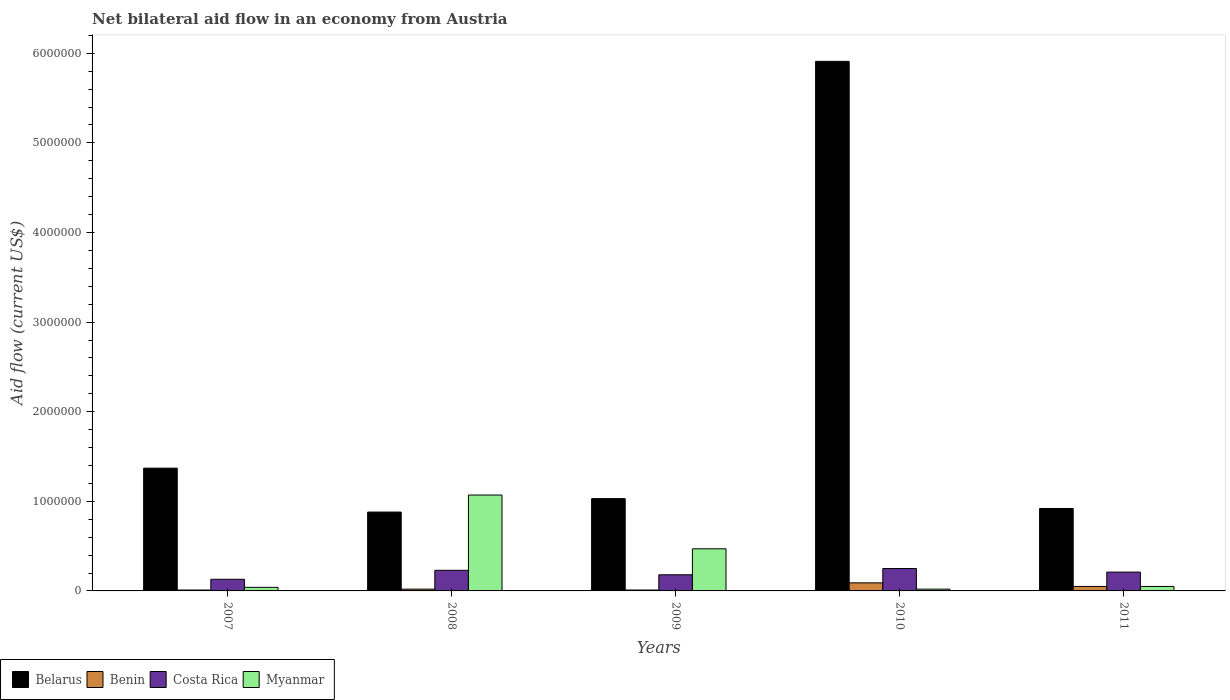How many groups of bars are there?
Make the answer very short. 5. Are the number of bars on each tick of the X-axis equal?
Ensure brevity in your answer.  Yes. How many bars are there on the 3rd tick from the left?
Give a very brief answer. 4. How many bars are there on the 5th tick from the right?
Keep it short and to the point. 4. In how many cases, is the number of bars for a given year not equal to the number of legend labels?
Your answer should be compact. 0. What is the net bilateral aid flow in Costa Rica in 2011?
Keep it short and to the point. 2.10e+05. Across all years, what is the maximum net bilateral aid flow in Belarus?
Offer a very short reply. 5.91e+06. What is the total net bilateral aid flow in Myanmar in the graph?
Provide a succinct answer. 1.65e+06. What is the difference between the net bilateral aid flow in Belarus in 2008 and the net bilateral aid flow in Costa Rica in 2011?
Provide a succinct answer. 6.70e+05. What is the average net bilateral aid flow in Belarus per year?
Your answer should be compact. 2.02e+06. In the year 2010, what is the difference between the net bilateral aid flow in Belarus and net bilateral aid flow in Costa Rica?
Your answer should be very brief. 5.66e+06. In how many years, is the net bilateral aid flow in Costa Rica greater than 2000000 US$?
Keep it short and to the point. 0. Is the difference between the net bilateral aid flow in Belarus in 2010 and 2011 greater than the difference between the net bilateral aid flow in Costa Rica in 2010 and 2011?
Keep it short and to the point. Yes. What is the difference between the highest and the second highest net bilateral aid flow in Benin?
Your answer should be compact. 4.00e+04. What is the difference between the highest and the lowest net bilateral aid flow in Costa Rica?
Make the answer very short. 1.20e+05. Is the sum of the net bilateral aid flow in Myanmar in 2008 and 2010 greater than the maximum net bilateral aid flow in Belarus across all years?
Your answer should be very brief. No. What does the 2nd bar from the left in 2007 represents?
Your answer should be very brief. Benin. What does the 4th bar from the right in 2008 represents?
Offer a very short reply. Belarus. Is it the case that in every year, the sum of the net bilateral aid flow in Belarus and net bilateral aid flow in Benin is greater than the net bilateral aid flow in Myanmar?
Provide a succinct answer. No. Are all the bars in the graph horizontal?
Offer a very short reply. No. How many years are there in the graph?
Offer a terse response. 5. Does the graph contain grids?
Your response must be concise. No. Where does the legend appear in the graph?
Provide a succinct answer. Bottom left. What is the title of the graph?
Give a very brief answer. Net bilateral aid flow in an economy from Austria. Does "Honduras" appear as one of the legend labels in the graph?
Ensure brevity in your answer.  No. What is the Aid flow (current US$) in Belarus in 2007?
Provide a succinct answer. 1.37e+06. What is the Aid flow (current US$) in Costa Rica in 2007?
Keep it short and to the point. 1.30e+05. What is the Aid flow (current US$) of Belarus in 2008?
Your response must be concise. 8.80e+05. What is the Aid flow (current US$) in Myanmar in 2008?
Provide a short and direct response. 1.07e+06. What is the Aid flow (current US$) in Belarus in 2009?
Provide a short and direct response. 1.03e+06. What is the Aid flow (current US$) of Benin in 2009?
Your response must be concise. 10000. What is the Aid flow (current US$) in Costa Rica in 2009?
Your answer should be compact. 1.80e+05. What is the Aid flow (current US$) in Belarus in 2010?
Your answer should be very brief. 5.91e+06. What is the Aid flow (current US$) in Benin in 2010?
Give a very brief answer. 9.00e+04. What is the Aid flow (current US$) of Costa Rica in 2010?
Your answer should be very brief. 2.50e+05. What is the Aid flow (current US$) in Myanmar in 2010?
Offer a terse response. 2.00e+04. What is the Aid flow (current US$) of Belarus in 2011?
Your answer should be very brief. 9.20e+05. What is the Aid flow (current US$) in Benin in 2011?
Your response must be concise. 5.00e+04. What is the Aid flow (current US$) of Costa Rica in 2011?
Provide a succinct answer. 2.10e+05. Across all years, what is the maximum Aid flow (current US$) in Belarus?
Keep it short and to the point. 5.91e+06. Across all years, what is the maximum Aid flow (current US$) of Benin?
Your answer should be compact. 9.00e+04. Across all years, what is the maximum Aid flow (current US$) in Myanmar?
Give a very brief answer. 1.07e+06. Across all years, what is the minimum Aid flow (current US$) in Belarus?
Your response must be concise. 8.80e+05. Across all years, what is the minimum Aid flow (current US$) of Costa Rica?
Provide a short and direct response. 1.30e+05. What is the total Aid flow (current US$) of Belarus in the graph?
Provide a short and direct response. 1.01e+07. What is the total Aid flow (current US$) in Benin in the graph?
Offer a very short reply. 1.80e+05. What is the total Aid flow (current US$) of Myanmar in the graph?
Provide a short and direct response. 1.65e+06. What is the difference between the Aid flow (current US$) in Benin in 2007 and that in 2008?
Offer a terse response. -10000. What is the difference between the Aid flow (current US$) in Costa Rica in 2007 and that in 2008?
Offer a terse response. -1.00e+05. What is the difference between the Aid flow (current US$) of Myanmar in 2007 and that in 2008?
Make the answer very short. -1.03e+06. What is the difference between the Aid flow (current US$) in Benin in 2007 and that in 2009?
Give a very brief answer. 0. What is the difference between the Aid flow (current US$) of Myanmar in 2007 and that in 2009?
Give a very brief answer. -4.30e+05. What is the difference between the Aid flow (current US$) of Belarus in 2007 and that in 2010?
Provide a succinct answer. -4.54e+06. What is the difference between the Aid flow (current US$) of Costa Rica in 2007 and that in 2010?
Keep it short and to the point. -1.20e+05. What is the difference between the Aid flow (current US$) in Belarus in 2007 and that in 2011?
Offer a very short reply. 4.50e+05. What is the difference between the Aid flow (current US$) of Benin in 2007 and that in 2011?
Provide a succinct answer. -4.00e+04. What is the difference between the Aid flow (current US$) in Belarus in 2008 and that in 2009?
Give a very brief answer. -1.50e+05. What is the difference between the Aid flow (current US$) in Benin in 2008 and that in 2009?
Offer a terse response. 10000. What is the difference between the Aid flow (current US$) in Costa Rica in 2008 and that in 2009?
Give a very brief answer. 5.00e+04. What is the difference between the Aid flow (current US$) in Myanmar in 2008 and that in 2009?
Offer a very short reply. 6.00e+05. What is the difference between the Aid flow (current US$) of Belarus in 2008 and that in 2010?
Ensure brevity in your answer.  -5.03e+06. What is the difference between the Aid flow (current US$) in Benin in 2008 and that in 2010?
Keep it short and to the point. -7.00e+04. What is the difference between the Aid flow (current US$) of Myanmar in 2008 and that in 2010?
Ensure brevity in your answer.  1.05e+06. What is the difference between the Aid flow (current US$) in Myanmar in 2008 and that in 2011?
Your answer should be very brief. 1.02e+06. What is the difference between the Aid flow (current US$) in Belarus in 2009 and that in 2010?
Provide a succinct answer. -4.88e+06. What is the difference between the Aid flow (current US$) of Costa Rica in 2009 and that in 2011?
Your answer should be very brief. -3.00e+04. What is the difference between the Aid flow (current US$) in Belarus in 2010 and that in 2011?
Your answer should be compact. 4.99e+06. What is the difference between the Aid flow (current US$) in Benin in 2010 and that in 2011?
Ensure brevity in your answer.  4.00e+04. What is the difference between the Aid flow (current US$) in Costa Rica in 2010 and that in 2011?
Offer a very short reply. 4.00e+04. What is the difference between the Aid flow (current US$) of Myanmar in 2010 and that in 2011?
Offer a very short reply. -3.00e+04. What is the difference between the Aid flow (current US$) of Belarus in 2007 and the Aid flow (current US$) of Benin in 2008?
Your response must be concise. 1.35e+06. What is the difference between the Aid flow (current US$) of Belarus in 2007 and the Aid flow (current US$) of Costa Rica in 2008?
Give a very brief answer. 1.14e+06. What is the difference between the Aid flow (current US$) in Benin in 2007 and the Aid flow (current US$) in Myanmar in 2008?
Give a very brief answer. -1.06e+06. What is the difference between the Aid flow (current US$) in Costa Rica in 2007 and the Aid flow (current US$) in Myanmar in 2008?
Ensure brevity in your answer.  -9.40e+05. What is the difference between the Aid flow (current US$) in Belarus in 2007 and the Aid flow (current US$) in Benin in 2009?
Your response must be concise. 1.36e+06. What is the difference between the Aid flow (current US$) of Belarus in 2007 and the Aid flow (current US$) of Costa Rica in 2009?
Provide a succinct answer. 1.19e+06. What is the difference between the Aid flow (current US$) of Belarus in 2007 and the Aid flow (current US$) of Myanmar in 2009?
Offer a terse response. 9.00e+05. What is the difference between the Aid flow (current US$) of Benin in 2007 and the Aid flow (current US$) of Costa Rica in 2009?
Keep it short and to the point. -1.70e+05. What is the difference between the Aid flow (current US$) of Benin in 2007 and the Aid flow (current US$) of Myanmar in 2009?
Provide a short and direct response. -4.60e+05. What is the difference between the Aid flow (current US$) in Belarus in 2007 and the Aid flow (current US$) in Benin in 2010?
Make the answer very short. 1.28e+06. What is the difference between the Aid flow (current US$) in Belarus in 2007 and the Aid flow (current US$) in Costa Rica in 2010?
Your response must be concise. 1.12e+06. What is the difference between the Aid flow (current US$) in Belarus in 2007 and the Aid flow (current US$) in Myanmar in 2010?
Make the answer very short. 1.35e+06. What is the difference between the Aid flow (current US$) in Benin in 2007 and the Aid flow (current US$) in Costa Rica in 2010?
Keep it short and to the point. -2.40e+05. What is the difference between the Aid flow (current US$) of Belarus in 2007 and the Aid flow (current US$) of Benin in 2011?
Give a very brief answer. 1.32e+06. What is the difference between the Aid flow (current US$) in Belarus in 2007 and the Aid flow (current US$) in Costa Rica in 2011?
Provide a succinct answer. 1.16e+06. What is the difference between the Aid flow (current US$) in Belarus in 2007 and the Aid flow (current US$) in Myanmar in 2011?
Provide a short and direct response. 1.32e+06. What is the difference between the Aid flow (current US$) in Benin in 2007 and the Aid flow (current US$) in Costa Rica in 2011?
Your answer should be compact. -2.00e+05. What is the difference between the Aid flow (current US$) of Benin in 2007 and the Aid flow (current US$) of Myanmar in 2011?
Keep it short and to the point. -4.00e+04. What is the difference between the Aid flow (current US$) of Belarus in 2008 and the Aid flow (current US$) of Benin in 2009?
Your answer should be compact. 8.70e+05. What is the difference between the Aid flow (current US$) of Belarus in 2008 and the Aid flow (current US$) of Costa Rica in 2009?
Make the answer very short. 7.00e+05. What is the difference between the Aid flow (current US$) of Benin in 2008 and the Aid flow (current US$) of Myanmar in 2009?
Provide a short and direct response. -4.50e+05. What is the difference between the Aid flow (current US$) of Costa Rica in 2008 and the Aid flow (current US$) of Myanmar in 2009?
Your response must be concise. -2.40e+05. What is the difference between the Aid flow (current US$) in Belarus in 2008 and the Aid flow (current US$) in Benin in 2010?
Keep it short and to the point. 7.90e+05. What is the difference between the Aid flow (current US$) of Belarus in 2008 and the Aid flow (current US$) of Costa Rica in 2010?
Your response must be concise. 6.30e+05. What is the difference between the Aid flow (current US$) of Belarus in 2008 and the Aid flow (current US$) of Myanmar in 2010?
Your answer should be very brief. 8.60e+05. What is the difference between the Aid flow (current US$) of Benin in 2008 and the Aid flow (current US$) of Costa Rica in 2010?
Your response must be concise. -2.30e+05. What is the difference between the Aid flow (current US$) of Benin in 2008 and the Aid flow (current US$) of Myanmar in 2010?
Offer a very short reply. 0. What is the difference between the Aid flow (current US$) in Costa Rica in 2008 and the Aid flow (current US$) in Myanmar in 2010?
Make the answer very short. 2.10e+05. What is the difference between the Aid flow (current US$) in Belarus in 2008 and the Aid flow (current US$) in Benin in 2011?
Make the answer very short. 8.30e+05. What is the difference between the Aid flow (current US$) in Belarus in 2008 and the Aid flow (current US$) in Costa Rica in 2011?
Your response must be concise. 6.70e+05. What is the difference between the Aid flow (current US$) in Belarus in 2008 and the Aid flow (current US$) in Myanmar in 2011?
Provide a succinct answer. 8.30e+05. What is the difference between the Aid flow (current US$) in Belarus in 2009 and the Aid flow (current US$) in Benin in 2010?
Give a very brief answer. 9.40e+05. What is the difference between the Aid flow (current US$) in Belarus in 2009 and the Aid flow (current US$) in Costa Rica in 2010?
Provide a succinct answer. 7.80e+05. What is the difference between the Aid flow (current US$) of Belarus in 2009 and the Aid flow (current US$) of Myanmar in 2010?
Provide a succinct answer. 1.01e+06. What is the difference between the Aid flow (current US$) in Belarus in 2009 and the Aid flow (current US$) in Benin in 2011?
Your answer should be compact. 9.80e+05. What is the difference between the Aid flow (current US$) of Belarus in 2009 and the Aid flow (current US$) of Costa Rica in 2011?
Your response must be concise. 8.20e+05. What is the difference between the Aid flow (current US$) in Belarus in 2009 and the Aid flow (current US$) in Myanmar in 2011?
Provide a succinct answer. 9.80e+05. What is the difference between the Aid flow (current US$) in Benin in 2009 and the Aid flow (current US$) in Costa Rica in 2011?
Provide a short and direct response. -2.00e+05. What is the difference between the Aid flow (current US$) of Costa Rica in 2009 and the Aid flow (current US$) of Myanmar in 2011?
Offer a very short reply. 1.30e+05. What is the difference between the Aid flow (current US$) in Belarus in 2010 and the Aid flow (current US$) in Benin in 2011?
Offer a very short reply. 5.86e+06. What is the difference between the Aid flow (current US$) in Belarus in 2010 and the Aid flow (current US$) in Costa Rica in 2011?
Give a very brief answer. 5.70e+06. What is the difference between the Aid flow (current US$) of Belarus in 2010 and the Aid flow (current US$) of Myanmar in 2011?
Your answer should be very brief. 5.86e+06. What is the difference between the Aid flow (current US$) of Benin in 2010 and the Aid flow (current US$) of Costa Rica in 2011?
Ensure brevity in your answer.  -1.20e+05. What is the difference between the Aid flow (current US$) of Costa Rica in 2010 and the Aid flow (current US$) of Myanmar in 2011?
Provide a short and direct response. 2.00e+05. What is the average Aid flow (current US$) in Belarus per year?
Make the answer very short. 2.02e+06. What is the average Aid flow (current US$) of Benin per year?
Offer a very short reply. 3.60e+04. What is the average Aid flow (current US$) in Costa Rica per year?
Provide a succinct answer. 2.00e+05. In the year 2007, what is the difference between the Aid flow (current US$) in Belarus and Aid flow (current US$) in Benin?
Your answer should be very brief. 1.36e+06. In the year 2007, what is the difference between the Aid flow (current US$) in Belarus and Aid flow (current US$) in Costa Rica?
Your answer should be very brief. 1.24e+06. In the year 2007, what is the difference between the Aid flow (current US$) in Belarus and Aid flow (current US$) in Myanmar?
Offer a terse response. 1.33e+06. In the year 2007, what is the difference between the Aid flow (current US$) of Benin and Aid flow (current US$) of Myanmar?
Keep it short and to the point. -3.00e+04. In the year 2008, what is the difference between the Aid flow (current US$) in Belarus and Aid flow (current US$) in Benin?
Provide a succinct answer. 8.60e+05. In the year 2008, what is the difference between the Aid flow (current US$) of Belarus and Aid flow (current US$) of Costa Rica?
Your response must be concise. 6.50e+05. In the year 2008, what is the difference between the Aid flow (current US$) of Belarus and Aid flow (current US$) of Myanmar?
Your answer should be compact. -1.90e+05. In the year 2008, what is the difference between the Aid flow (current US$) in Benin and Aid flow (current US$) in Myanmar?
Provide a short and direct response. -1.05e+06. In the year 2008, what is the difference between the Aid flow (current US$) in Costa Rica and Aid flow (current US$) in Myanmar?
Offer a very short reply. -8.40e+05. In the year 2009, what is the difference between the Aid flow (current US$) in Belarus and Aid flow (current US$) in Benin?
Ensure brevity in your answer.  1.02e+06. In the year 2009, what is the difference between the Aid flow (current US$) of Belarus and Aid flow (current US$) of Costa Rica?
Make the answer very short. 8.50e+05. In the year 2009, what is the difference between the Aid flow (current US$) of Belarus and Aid flow (current US$) of Myanmar?
Ensure brevity in your answer.  5.60e+05. In the year 2009, what is the difference between the Aid flow (current US$) in Benin and Aid flow (current US$) in Myanmar?
Your response must be concise. -4.60e+05. In the year 2009, what is the difference between the Aid flow (current US$) of Costa Rica and Aid flow (current US$) of Myanmar?
Your response must be concise. -2.90e+05. In the year 2010, what is the difference between the Aid flow (current US$) of Belarus and Aid flow (current US$) of Benin?
Your response must be concise. 5.82e+06. In the year 2010, what is the difference between the Aid flow (current US$) of Belarus and Aid flow (current US$) of Costa Rica?
Keep it short and to the point. 5.66e+06. In the year 2010, what is the difference between the Aid flow (current US$) in Belarus and Aid flow (current US$) in Myanmar?
Your response must be concise. 5.89e+06. In the year 2010, what is the difference between the Aid flow (current US$) of Benin and Aid flow (current US$) of Costa Rica?
Offer a terse response. -1.60e+05. In the year 2010, what is the difference between the Aid flow (current US$) of Benin and Aid flow (current US$) of Myanmar?
Provide a succinct answer. 7.00e+04. In the year 2010, what is the difference between the Aid flow (current US$) of Costa Rica and Aid flow (current US$) of Myanmar?
Give a very brief answer. 2.30e+05. In the year 2011, what is the difference between the Aid flow (current US$) in Belarus and Aid flow (current US$) in Benin?
Offer a very short reply. 8.70e+05. In the year 2011, what is the difference between the Aid flow (current US$) in Belarus and Aid flow (current US$) in Costa Rica?
Your answer should be very brief. 7.10e+05. In the year 2011, what is the difference between the Aid flow (current US$) in Belarus and Aid flow (current US$) in Myanmar?
Give a very brief answer. 8.70e+05. In the year 2011, what is the difference between the Aid flow (current US$) in Benin and Aid flow (current US$) in Costa Rica?
Keep it short and to the point. -1.60e+05. In the year 2011, what is the difference between the Aid flow (current US$) in Benin and Aid flow (current US$) in Myanmar?
Make the answer very short. 0. What is the ratio of the Aid flow (current US$) in Belarus in 2007 to that in 2008?
Provide a succinct answer. 1.56. What is the ratio of the Aid flow (current US$) of Benin in 2007 to that in 2008?
Offer a terse response. 0.5. What is the ratio of the Aid flow (current US$) in Costa Rica in 2007 to that in 2008?
Provide a succinct answer. 0.57. What is the ratio of the Aid flow (current US$) of Myanmar in 2007 to that in 2008?
Your response must be concise. 0.04. What is the ratio of the Aid flow (current US$) in Belarus in 2007 to that in 2009?
Your answer should be very brief. 1.33. What is the ratio of the Aid flow (current US$) of Costa Rica in 2007 to that in 2009?
Your answer should be very brief. 0.72. What is the ratio of the Aid flow (current US$) in Myanmar in 2007 to that in 2009?
Offer a terse response. 0.09. What is the ratio of the Aid flow (current US$) of Belarus in 2007 to that in 2010?
Your answer should be very brief. 0.23. What is the ratio of the Aid flow (current US$) in Benin in 2007 to that in 2010?
Your answer should be compact. 0.11. What is the ratio of the Aid flow (current US$) in Costa Rica in 2007 to that in 2010?
Provide a short and direct response. 0.52. What is the ratio of the Aid flow (current US$) of Belarus in 2007 to that in 2011?
Keep it short and to the point. 1.49. What is the ratio of the Aid flow (current US$) in Benin in 2007 to that in 2011?
Keep it short and to the point. 0.2. What is the ratio of the Aid flow (current US$) of Costa Rica in 2007 to that in 2011?
Your answer should be very brief. 0.62. What is the ratio of the Aid flow (current US$) in Belarus in 2008 to that in 2009?
Your response must be concise. 0.85. What is the ratio of the Aid flow (current US$) of Costa Rica in 2008 to that in 2009?
Offer a very short reply. 1.28. What is the ratio of the Aid flow (current US$) in Myanmar in 2008 to that in 2009?
Your answer should be compact. 2.28. What is the ratio of the Aid flow (current US$) of Belarus in 2008 to that in 2010?
Provide a short and direct response. 0.15. What is the ratio of the Aid flow (current US$) of Benin in 2008 to that in 2010?
Your response must be concise. 0.22. What is the ratio of the Aid flow (current US$) of Myanmar in 2008 to that in 2010?
Offer a terse response. 53.5. What is the ratio of the Aid flow (current US$) in Belarus in 2008 to that in 2011?
Offer a terse response. 0.96. What is the ratio of the Aid flow (current US$) of Benin in 2008 to that in 2011?
Your response must be concise. 0.4. What is the ratio of the Aid flow (current US$) in Costa Rica in 2008 to that in 2011?
Give a very brief answer. 1.1. What is the ratio of the Aid flow (current US$) of Myanmar in 2008 to that in 2011?
Provide a short and direct response. 21.4. What is the ratio of the Aid flow (current US$) of Belarus in 2009 to that in 2010?
Your answer should be compact. 0.17. What is the ratio of the Aid flow (current US$) of Costa Rica in 2009 to that in 2010?
Your response must be concise. 0.72. What is the ratio of the Aid flow (current US$) in Belarus in 2009 to that in 2011?
Offer a terse response. 1.12. What is the ratio of the Aid flow (current US$) of Belarus in 2010 to that in 2011?
Your answer should be very brief. 6.42. What is the ratio of the Aid flow (current US$) of Costa Rica in 2010 to that in 2011?
Ensure brevity in your answer.  1.19. What is the ratio of the Aid flow (current US$) in Myanmar in 2010 to that in 2011?
Provide a short and direct response. 0.4. What is the difference between the highest and the second highest Aid flow (current US$) of Belarus?
Ensure brevity in your answer.  4.54e+06. What is the difference between the highest and the second highest Aid flow (current US$) in Benin?
Your answer should be very brief. 4.00e+04. What is the difference between the highest and the second highest Aid flow (current US$) in Costa Rica?
Your answer should be compact. 2.00e+04. What is the difference between the highest and the second highest Aid flow (current US$) in Myanmar?
Your answer should be compact. 6.00e+05. What is the difference between the highest and the lowest Aid flow (current US$) of Belarus?
Ensure brevity in your answer.  5.03e+06. What is the difference between the highest and the lowest Aid flow (current US$) in Costa Rica?
Your answer should be compact. 1.20e+05. What is the difference between the highest and the lowest Aid flow (current US$) of Myanmar?
Offer a terse response. 1.05e+06. 